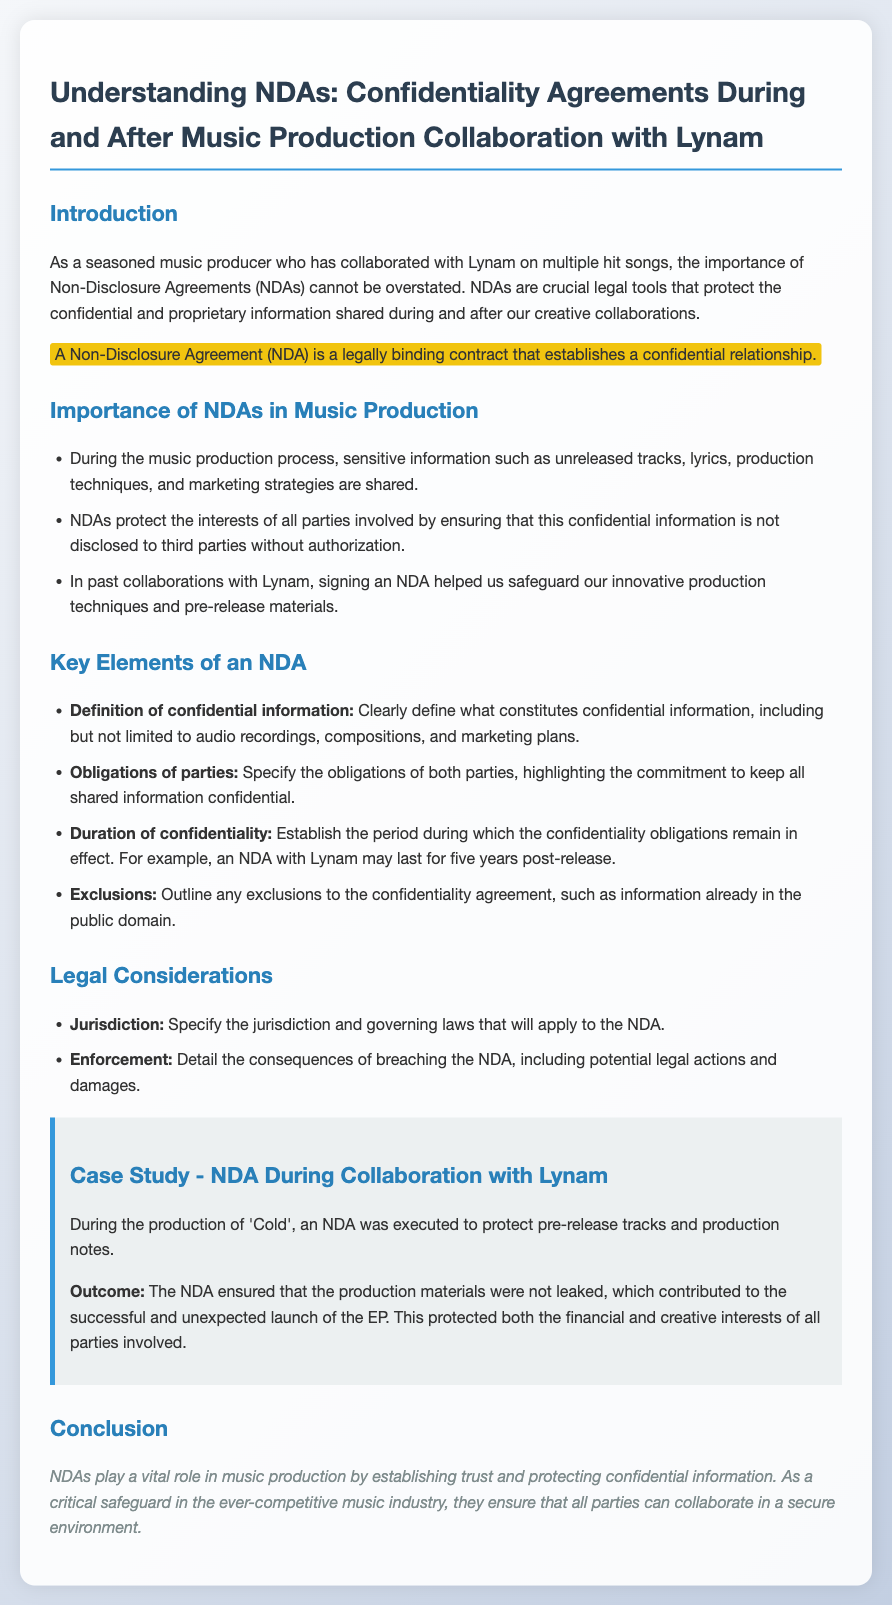What is a Non-Disclosure Agreement? A Non-Disclosure Agreement (NDA) is a legally binding contract that establishes a confidential relationship.
Answer: a legally binding contract What information is protected by NDAs during music production? The document mentions sensitive information such as unreleased tracks, lyrics, production techniques, and marketing strategies.
Answer: unreleased tracks, lyrics, production techniques, and marketing strategies How long may an NDA with Lynam last post-release? The text states that an NDA with Lynam may last for five years post-release.
Answer: five years What element defines what constitutes confidential information? The definition of confidential information involves audio recordings, compositions, and marketing plans.
Answer: confidential information What was the outcome of the NDA during the production of 'Cold'? The outcome was that the NDA ensured that the production materials were not leaked, which contributed to the successful release.
Answer: not leaked, contributed to the successful release What does the document say about the obligations of parties? The obligations of both parties include a commitment to keep all shared information confidential.
Answer: a commitment to keep all shared information confidential What legal aspect does the NDA specify regarding consequences of breaching it? The enforcement section details the consequences of breaching the NDA, including potential legal actions and damages.
Answer: potential legal actions and damages What role do NDAs play in music production? NDAs establish trust and protect confidential information in music production.
Answer: establish trust and protect confidential information 